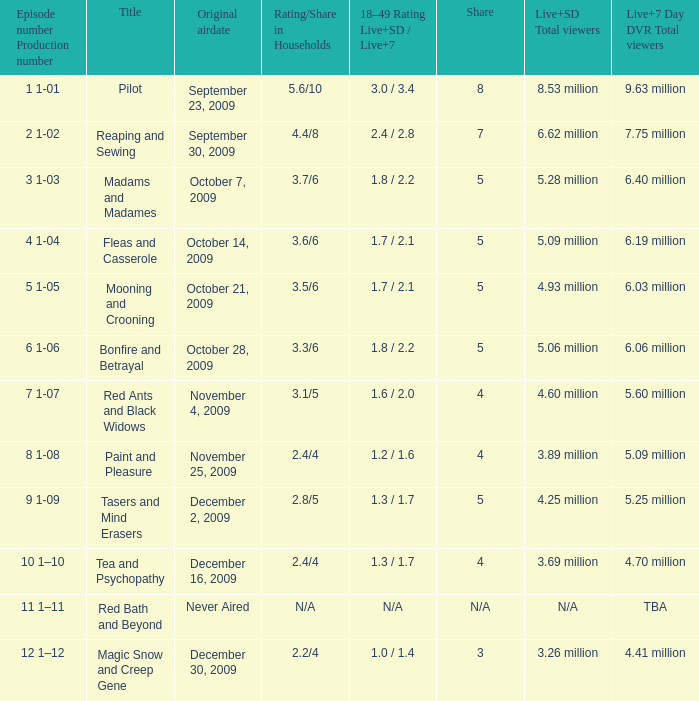How many total viewers (combined Live and SD) watched the episode with a share of 8? 9.63 million. 